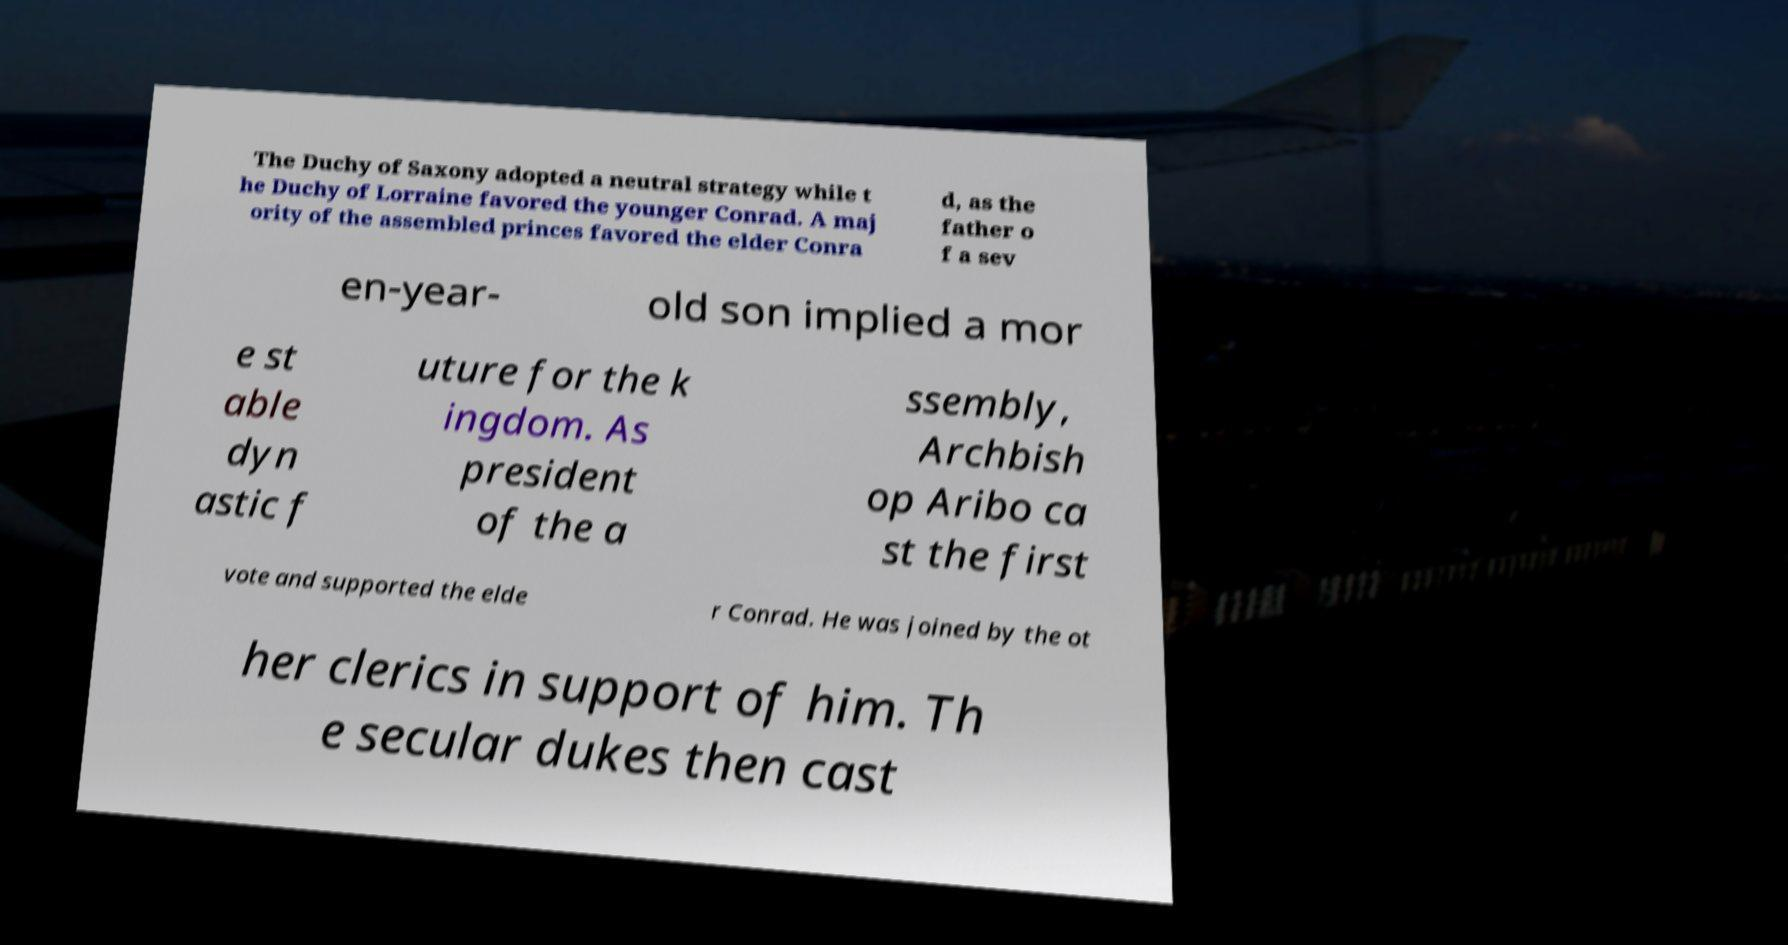Could you assist in decoding the text presented in this image and type it out clearly? The Duchy of Saxony adopted a neutral strategy while t he Duchy of Lorraine favored the younger Conrad. A maj ority of the assembled princes favored the elder Conra d, as the father o f a sev en-year- old son implied a mor e st able dyn astic f uture for the k ingdom. As president of the a ssembly, Archbish op Aribo ca st the first vote and supported the elde r Conrad. He was joined by the ot her clerics in support of him. Th e secular dukes then cast 